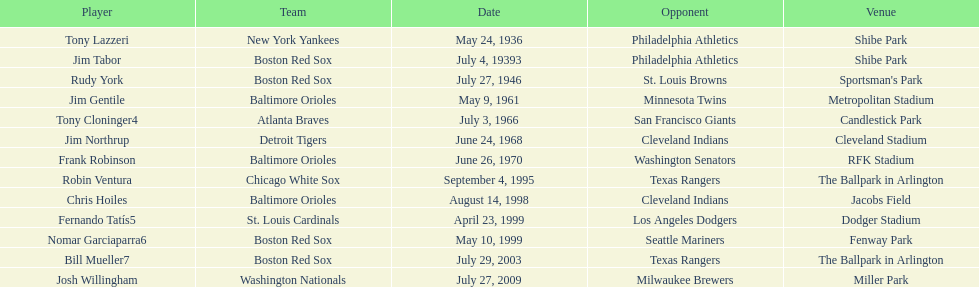Who is the first major league hitter to hit two grand slams in one game? Tony Lazzeri. 